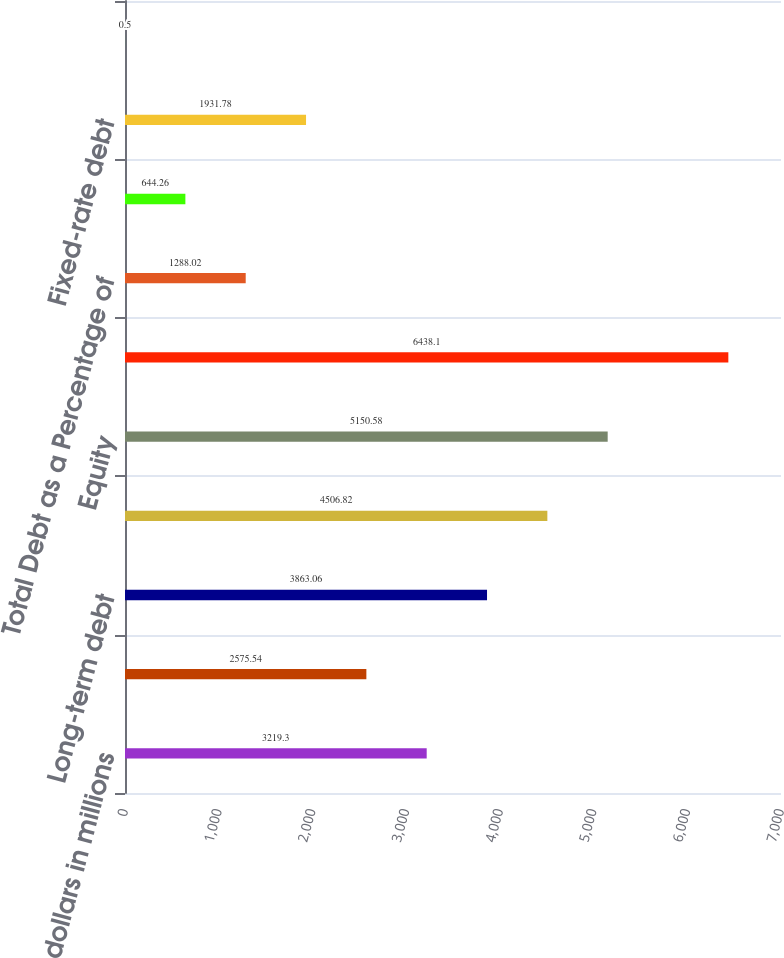<chart> <loc_0><loc_0><loc_500><loc_500><bar_chart><fcel>dollars in millions<fcel>Current maturities of<fcel>Long-term debt<fcel>Total debt<fcel>Equity<fcel>Total capital<fcel>Total Debt as a Percentage of<fcel>Long-term debt excluding bank<fcel>Fixed-rate debt<fcel>Floating-rate debt<nl><fcel>3219.3<fcel>2575.54<fcel>3863.06<fcel>4506.82<fcel>5150.58<fcel>6438.1<fcel>1288.02<fcel>644.26<fcel>1931.78<fcel>0.5<nl></chart> 